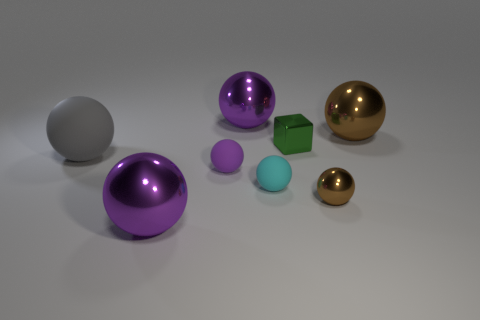Are there more large brown metal spheres to the right of the big gray matte ball than large brown shiny blocks?
Offer a terse response. Yes. What number of other things have the same size as the green object?
Offer a very short reply. 3. Is the size of the brown metallic ball in front of the cyan object the same as the purple rubber object that is on the left side of the small brown shiny sphere?
Give a very brief answer. Yes. What is the size of the brown metal ball in front of the cyan matte object?
Make the answer very short. Small. There is a block that is behind the object in front of the small brown object; how big is it?
Provide a succinct answer. Small. There is a purple ball that is the same size as the cyan matte object; what material is it?
Provide a succinct answer. Rubber. Are there any spheres to the right of the big gray thing?
Your answer should be compact. Yes. Are there an equal number of big rubber objects that are behind the cyan matte ball and yellow rubber cylinders?
Offer a terse response. No. The green thing that is the same size as the cyan rubber object is what shape?
Ensure brevity in your answer.  Cube. What is the material of the small green cube?
Give a very brief answer. Metal. 